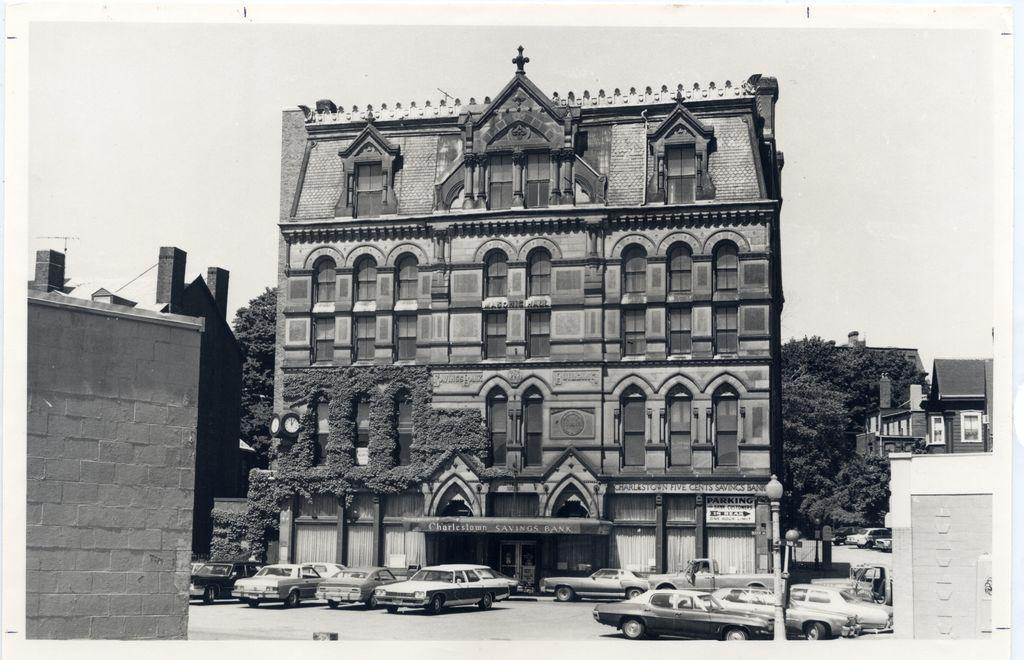What type of structure is present in the image? There is a building in the image. What is in front of the building? There are many cars in front of the building. Can you describe any other objects or features in the image? There is a pole visible in the image, and there are many trees and the sky visible in the background. How many fish can be seen swimming near the building in the image? There are no fish present in the image; it features a building, cars, a pole, trees, and the sky. Can you tell me how many dinosaurs are walking around the building in the image? There are no dinosaurs present in the image; it features a building, cars, a pole, trees, and the sky. 